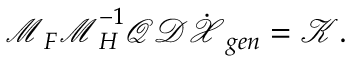<formula> <loc_0><loc_0><loc_500><loc_500>\mathcal { M } _ { F } \mathcal { M } _ { H } ^ { - 1 } \mathcal { Q } \mathcal { D } \dot { \mathcal { X } } _ { g e n } = \mathcal { K } .</formula> 